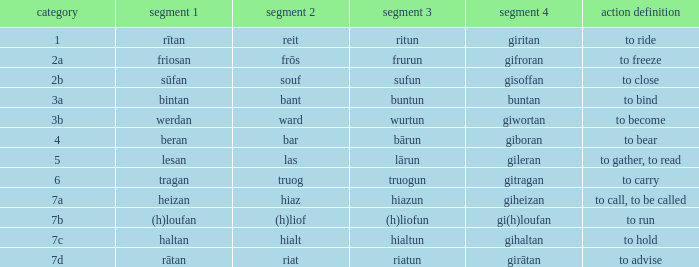What class in the word with part 4 "giheizan"? 7a. 